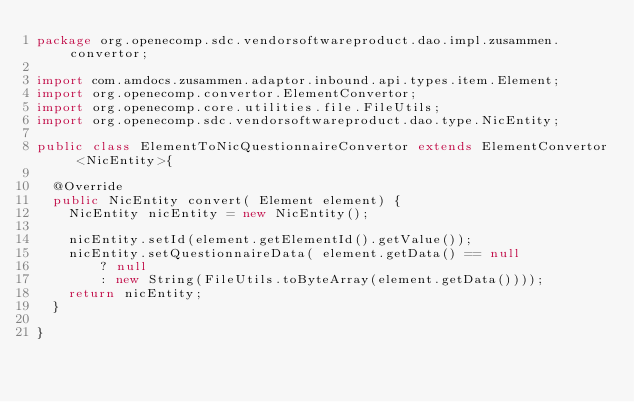<code> <loc_0><loc_0><loc_500><loc_500><_Java_>package org.openecomp.sdc.vendorsoftwareproduct.dao.impl.zusammen.convertor;

import com.amdocs.zusammen.adaptor.inbound.api.types.item.Element;
import org.openecomp.convertor.ElementConvertor;
import org.openecomp.core.utilities.file.FileUtils;
import org.openecomp.sdc.vendorsoftwareproduct.dao.type.NicEntity;

public class ElementToNicQuestionnaireConvertor extends ElementConvertor <NicEntity>{

  @Override
  public NicEntity convert( Element element) {
    NicEntity nicEntity = new NicEntity();

    nicEntity.setId(element.getElementId().getValue());
    nicEntity.setQuestionnaireData( element.getData() == null
        ? null
        : new String(FileUtils.toByteArray(element.getData())));
    return nicEntity;
  }

}
</code> 